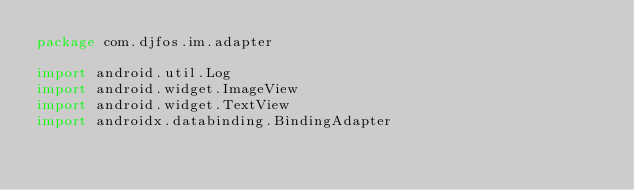<code> <loc_0><loc_0><loc_500><loc_500><_Kotlin_>package com.djfos.im.adapter

import android.util.Log
import android.widget.ImageView
import android.widget.TextView
import androidx.databinding.BindingAdapter</code> 